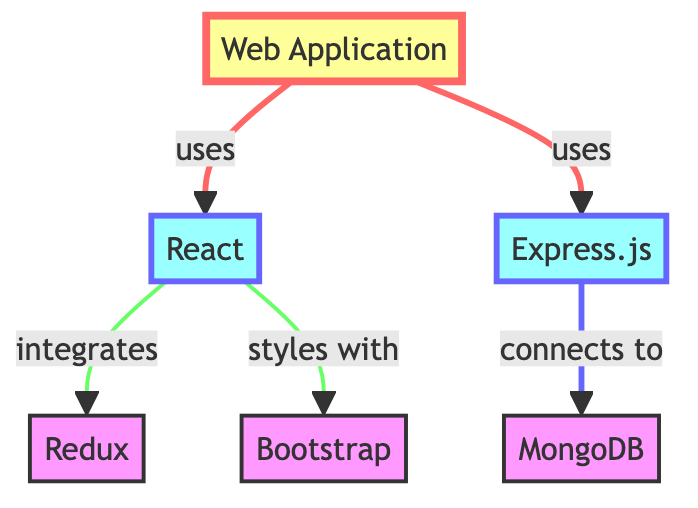What is the main web application in the diagram? The main web application, depicted as the central node, is "Web Application."
Answer: Web Application How many frameworks are used in this web application? There are three frameworks illustrated in the diagram: React, Express.js, and Bootstrap. Counting these gives a total of three frameworks.
Answer: 3 Which database is connected to the backend framework? The backend framework, Express.js, has a connection to the database, which is MongoDB, based on the directed edge in the diagram.
Answer: MongoDB What does the frontend framework integrate with? The frontend framework, React, integrates with State Management, which is represented by the node "Redux." This is confirmed by the directed edge in the diagram.
Answer: State Management How many edges are there in total? By counting the connections (edges) represented in the diagram, there are a total of five edges linking the various nodes.
Answer: 5 What is the relationship between the web application and the frontend framework? The relationship is displayed as a directed edge from "Web Application" to "React," indicating that the web application uses the frontend framework.
Answer: uses What can you say about the CSS framework in terms of its relationship? The CSS framework, Bootstrap, is utilized for styling by the frontend framework, React, which is indicated by the edge connecting these two nodes.
Answer: styles with Which framework does the state management belong to? The state management is specifically indicated as "Redux" and is directly associated with the frontend framework, React, denoting that it belongs to this framework contextually.
Answer: React Is there a direct connection between the frontend and backend frameworks? No, there is no direct edge connecting the frontend framework (React) and the backend framework (Express.js) in the diagram. The connections are indirect; rather, they both connect to the web application.
Answer: No 